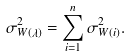<formula> <loc_0><loc_0><loc_500><loc_500>\sigma _ { W ( \lambda ) } ^ { 2 } = \sum _ { i = 1 } ^ { n } \sigma _ { W ( i ) } ^ { 2 } .</formula> 